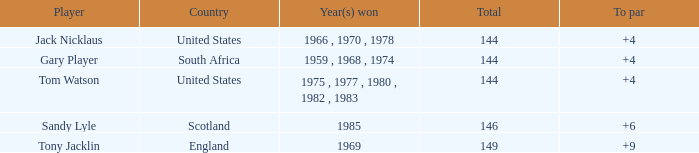Can you give me this table as a dict? {'header': ['Player', 'Country', 'Year(s) won', 'Total', 'To par'], 'rows': [['Jack Nicklaus', 'United States', '1966 , 1970 , 1978', '144', '+4'], ['Gary Player', 'South Africa', '1959 , 1968 , 1974', '144', '+4'], ['Tom Watson', 'United States', '1975 , 1977 , 1980 , 1982 , 1983', '144', '+4'], ['Sandy Lyle', 'Scotland', '1985', '146', '+6'], ['Tony Jacklin', 'England', '1969', '149', '+9']]} What was england's overall sum? 149.0. 